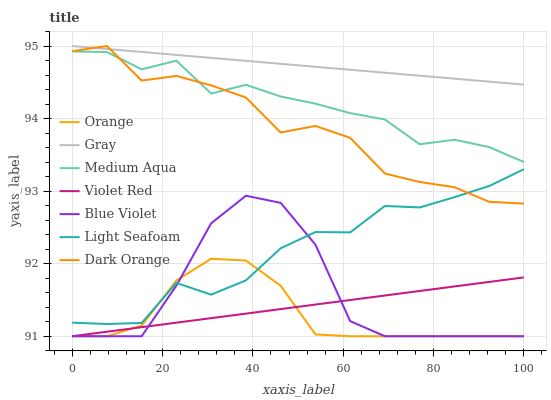Does Orange have the minimum area under the curve?
Answer yes or no. Yes. Does Gray have the maximum area under the curve?
Answer yes or no. Yes. Does Violet Red have the minimum area under the curve?
Answer yes or no. No. Does Violet Red have the maximum area under the curve?
Answer yes or no. No. Is Violet Red the smoothest?
Answer yes or no. Yes. Is Blue Violet the roughest?
Answer yes or no. Yes. Is Dark Orange the smoothest?
Answer yes or no. No. Is Dark Orange the roughest?
Answer yes or no. No. Does Violet Red have the lowest value?
Answer yes or no. Yes. Does Dark Orange have the lowest value?
Answer yes or no. No. Does Dark Orange have the highest value?
Answer yes or no. Yes. Does Violet Red have the highest value?
Answer yes or no. No. Is Orange less than Gray?
Answer yes or no. Yes. Is Medium Aqua greater than Light Seafoam?
Answer yes or no. Yes. Does Light Seafoam intersect Dark Orange?
Answer yes or no. Yes. Is Light Seafoam less than Dark Orange?
Answer yes or no. No. Is Light Seafoam greater than Dark Orange?
Answer yes or no. No. Does Orange intersect Gray?
Answer yes or no. No. 